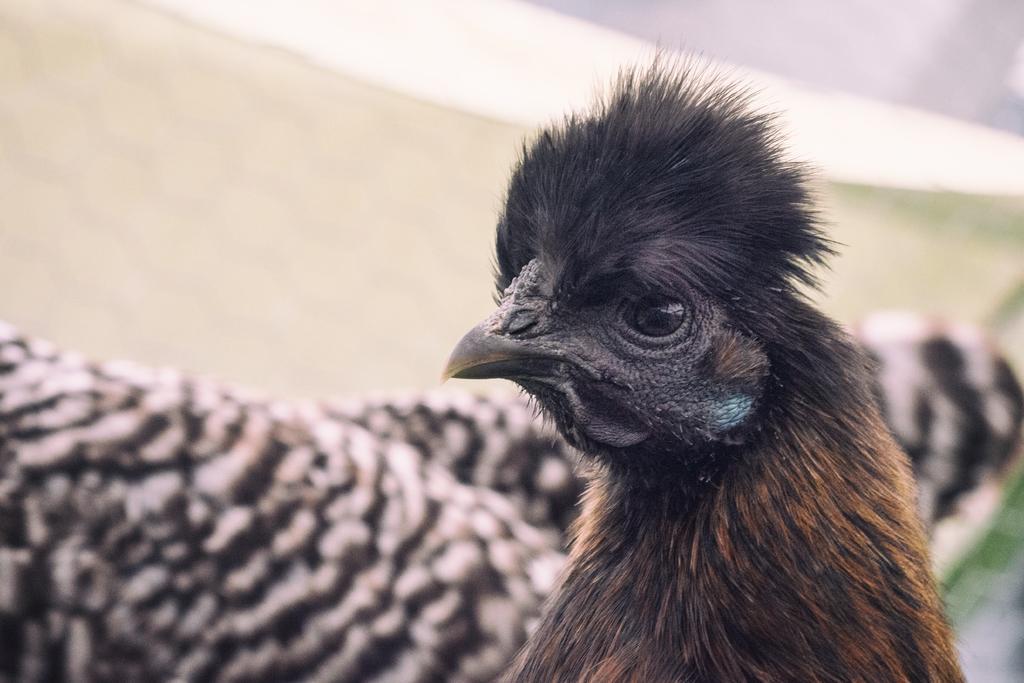Please provide a concise description of this image. In this image I can see bird which is in brown and black color. Back Side I can see white and cream color background. 